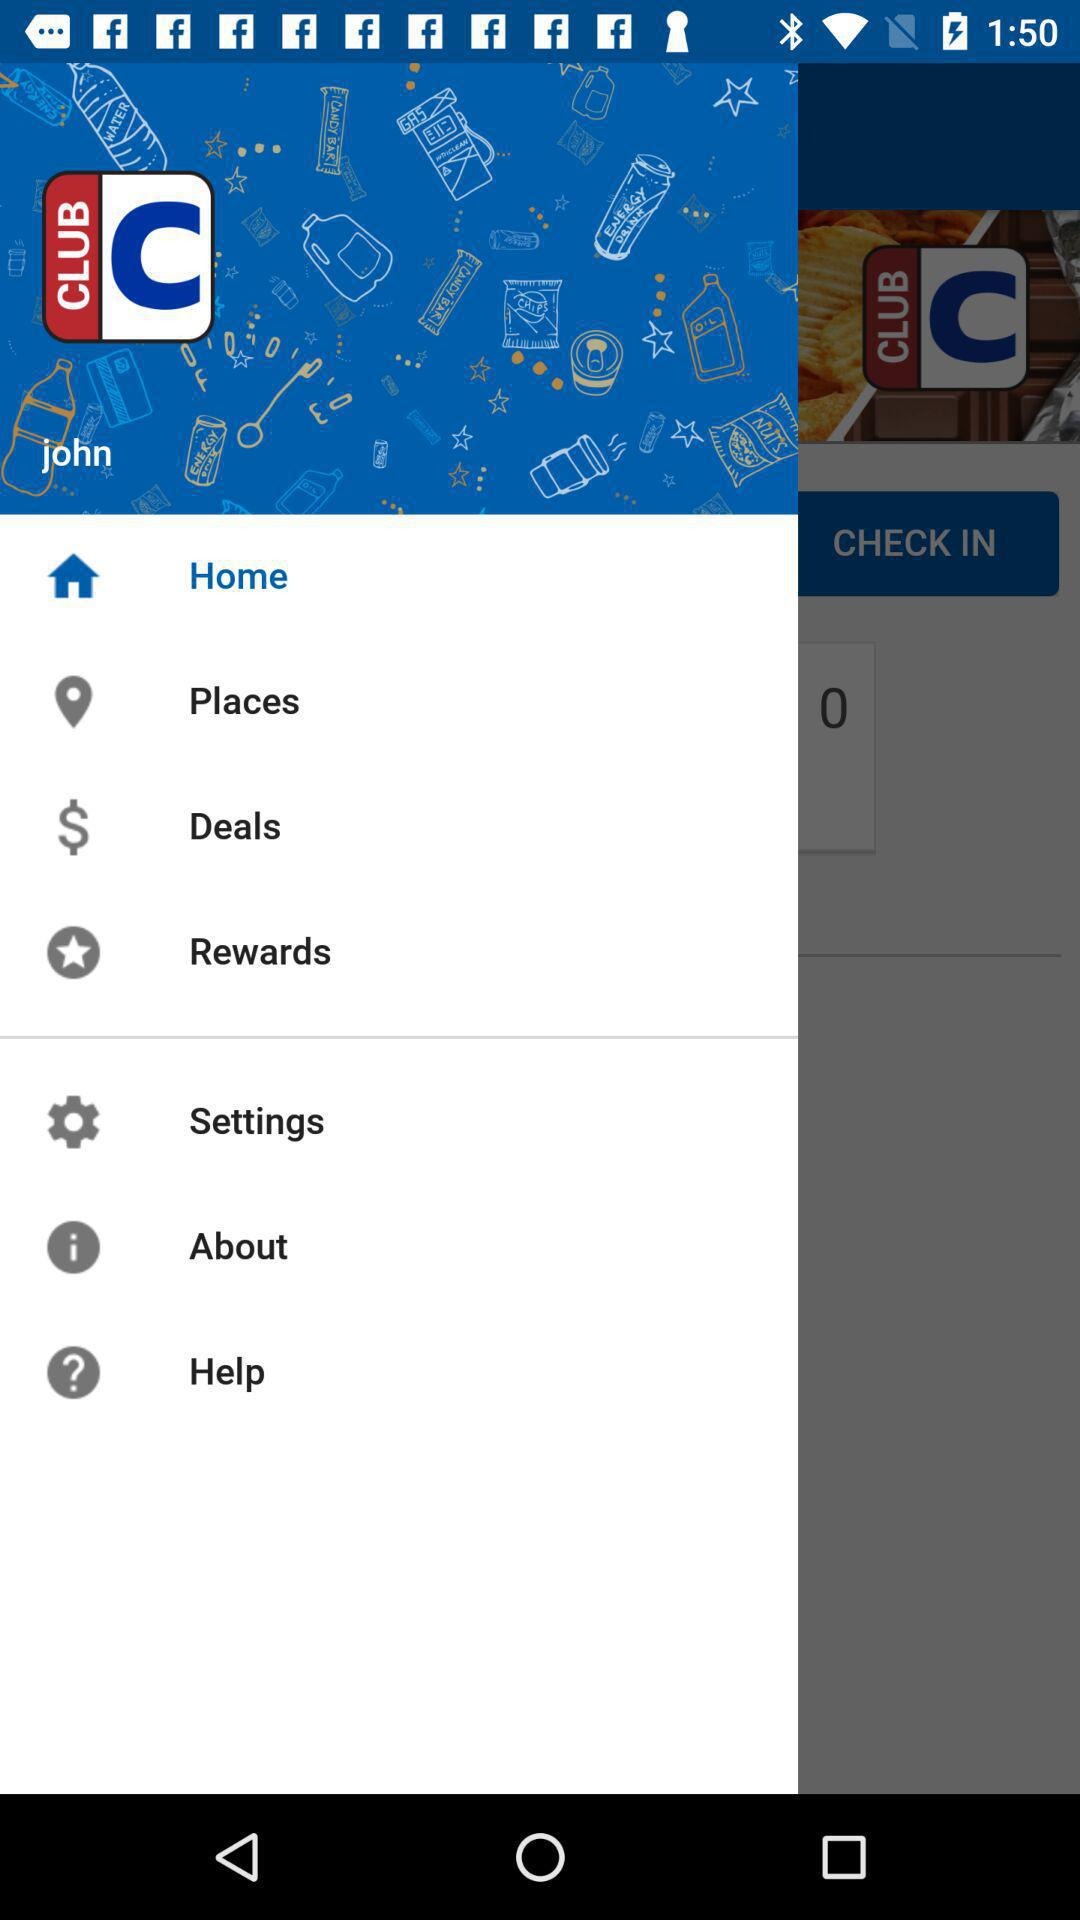What is the application name? The application name is "Club CITGO". 